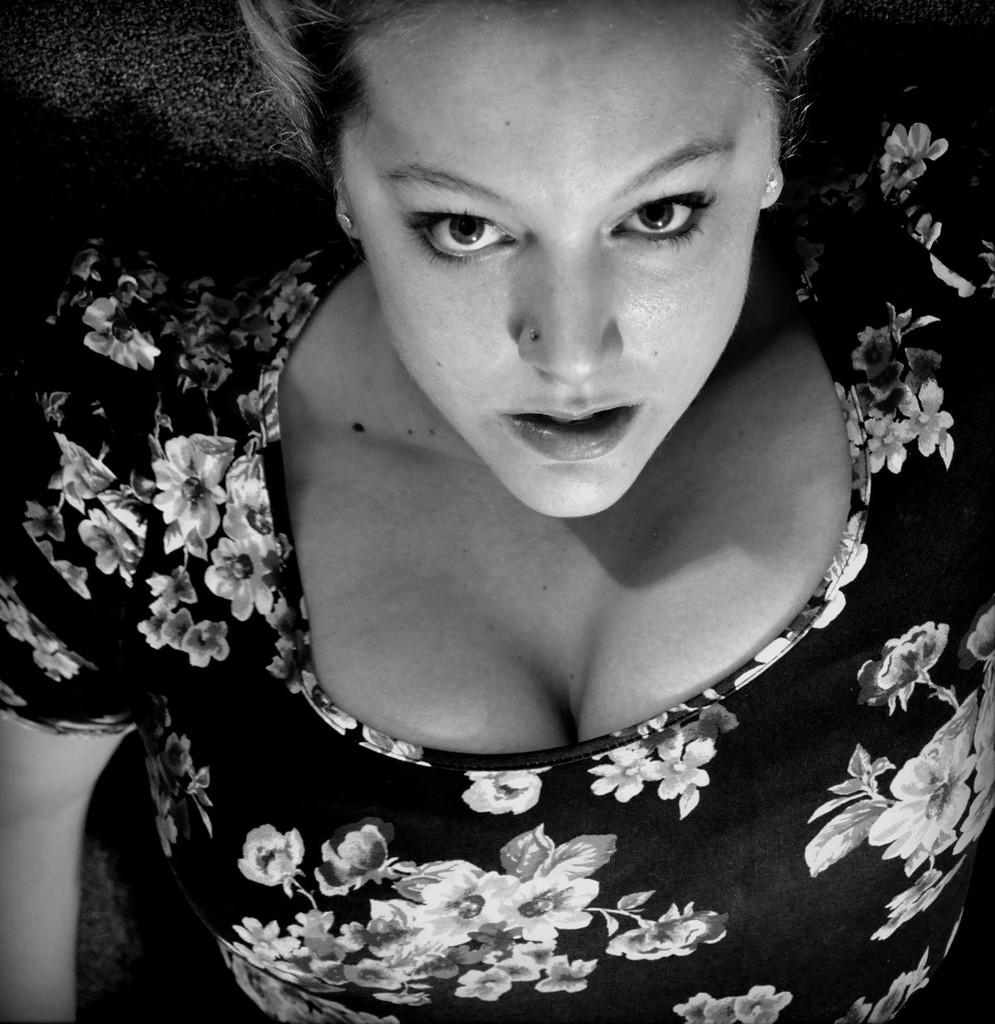What is the color scheme of the image? The image is black and white. Who is present in the image? There is a woman in the image. What is the woman wearing? The woman is wearing a dress. What is the woman's position in the image? The woman is lying on a surface. What type of circle can be seen in the image? There is no circle present in the image. Is there a bat flying in the image? There is no bat present in the image. 